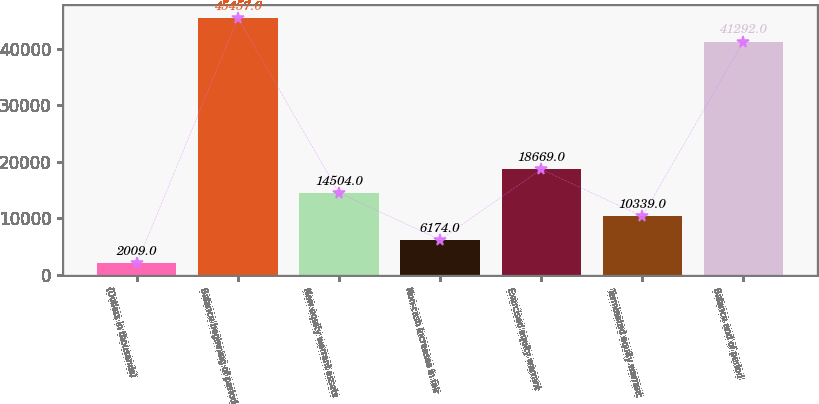Convert chart to OTSL. <chart><loc_0><loc_0><loc_500><loc_500><bar_chart><fcel>(Dollars in thousands)<fcel>Balance beginning of period<fcel>New equity warrant assets<fcel>Non-cash increases in fair<fcel>Exercised equity warrant<fcel>Terminated equity warrant<fcel>Balance end of period<nl><fcel>2009<fcel>45457<fcel>14504<fcel>6174<fcel>18669<fcel>10339<fcel>41292<nl></chart> 